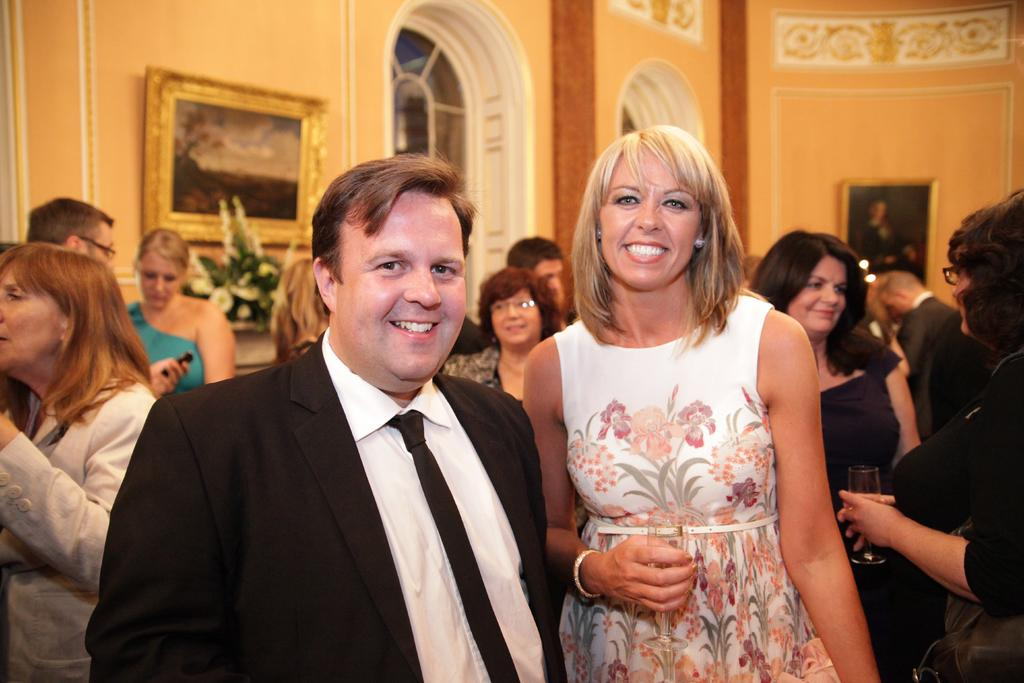What are the people in the image doing? The persons standing on the floor are likely engaged in some activity or standing in a particular setting. What can be seen in the background of the image? There are wall hangings, windows, walls, and flowers visible in the background. Can you describe the wall hangings in the image? Unfortunately, the details of the wall hangings cannot be determined from the provided facts. What type of arch can be seen in the image? There is no arch present in the image. What letters are visible on the wall hangings in the image? The details of the wall hangings, including any letters, cannot be determined from the provided facts. 